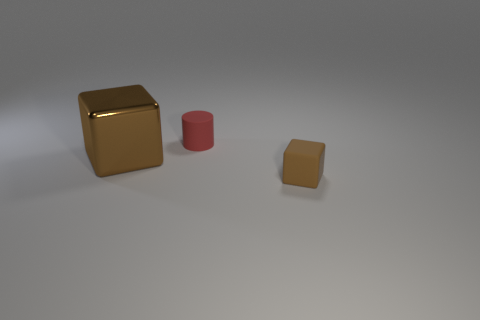There is a thing that is both on the right side of the large block and in front of the tiny red cylinder; what color is it?
Provide a succinct answer. Brown. Are there fewer small brown matte things that are left of the small rubber block than tiny rubber cylinders behind the red matte cylinder?
Give a very brief answer. No. What number of tiny rubber objects are the same shape as the large brown thing?
Offer a terse response. 1. There is a brown block that is the same material as the red thing; what is its size?
Your response must be concise. Small. The small thing that is on the right side of the small red thing right of the brown metal object is what color?
Ensure brevity in your answer.  Brown. There is a big metallic thing; is its shape the same as the thing that is behind the shiny object?
Make the answer very short. No. What number of brown rubber blocks are the same size as the cylinder?
Your answer should be very brief. 1. There is a large object that is the same shape as the small brown thing; what material is it?
Provide a succinct answer. Metal. Is the color of the small matte object that is behind the brown metallic block the same as the small rubber thing that is in front of the metallic block?
Give a very brief answer. No. The tiny object that is behind the big cube has what shape?
Offer a very short reply. Cylinder. 